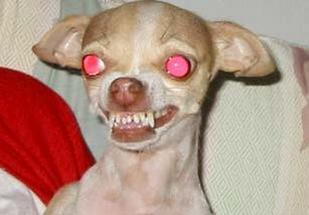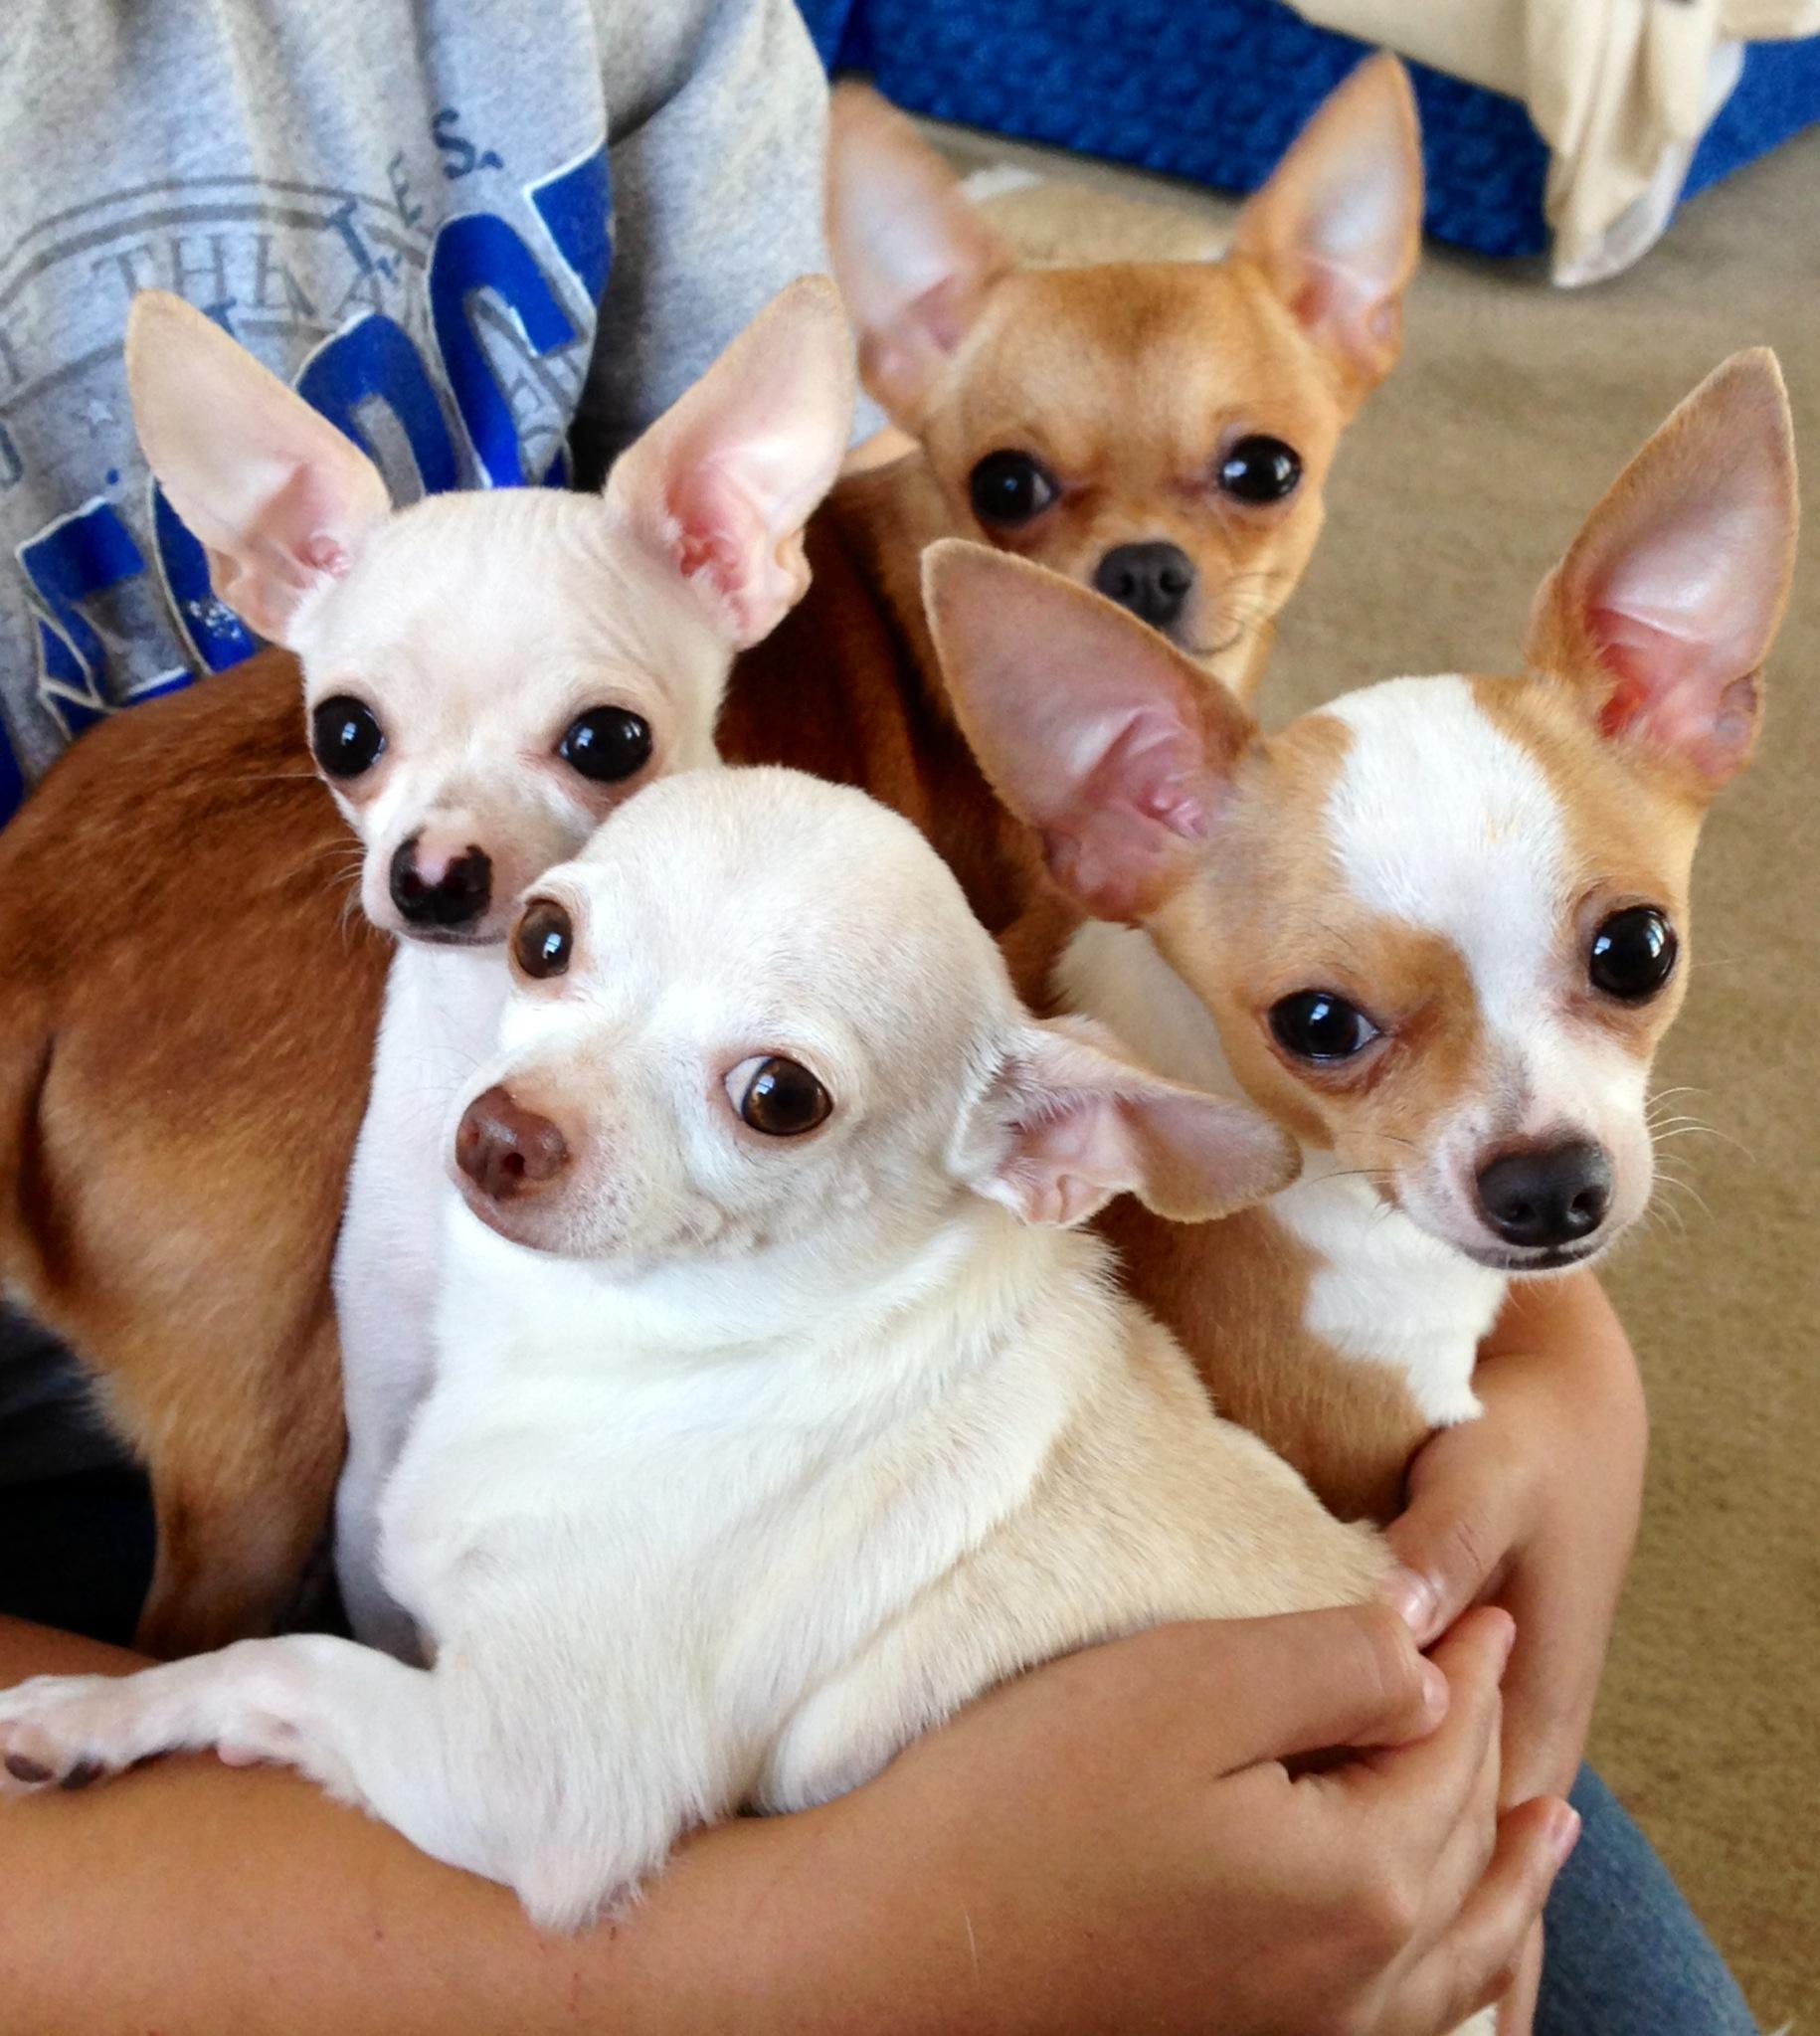The first image is the image on the left, the second image is the image on the right. Examine the images to the left and right. Is the description "One image shows one tan dog wearing a collar, and the other image includes at least one chihuahua wearing something hot pink." accurate? Answer yes or no. No. The first image is the image on the left, the second image is the image on the right. For the images displayed, is the sentence "There are four dogs in one image and the other has only one." factually correct? Answer yes or no. Yes. 